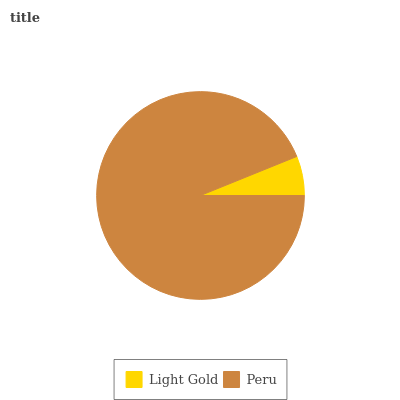Is Light Gold the minimum?
Answer yes or no. Yes. Is Peru the maximum?
Answer yes or no. Yes. Is Peru the minimum?
Answer yes or no. No. Is Peru greater than Light Gold?
Answer yes or no. Yes. Is Light Gold less than Peru?
Answer yes or no. Yes. Is Light Gold greater than Peru?
Answer yes or no. No. Is Peru less than Light Gold?
Answer yes or no. No. Is Peru the high median?
Answer yes or no. Yes. Is Light Gold the low median?
Answer yes or no. Yes. Is Light Gold the high median?
Answer yes or no. No. Is Peru the low median?
Answer yes or no. No. 